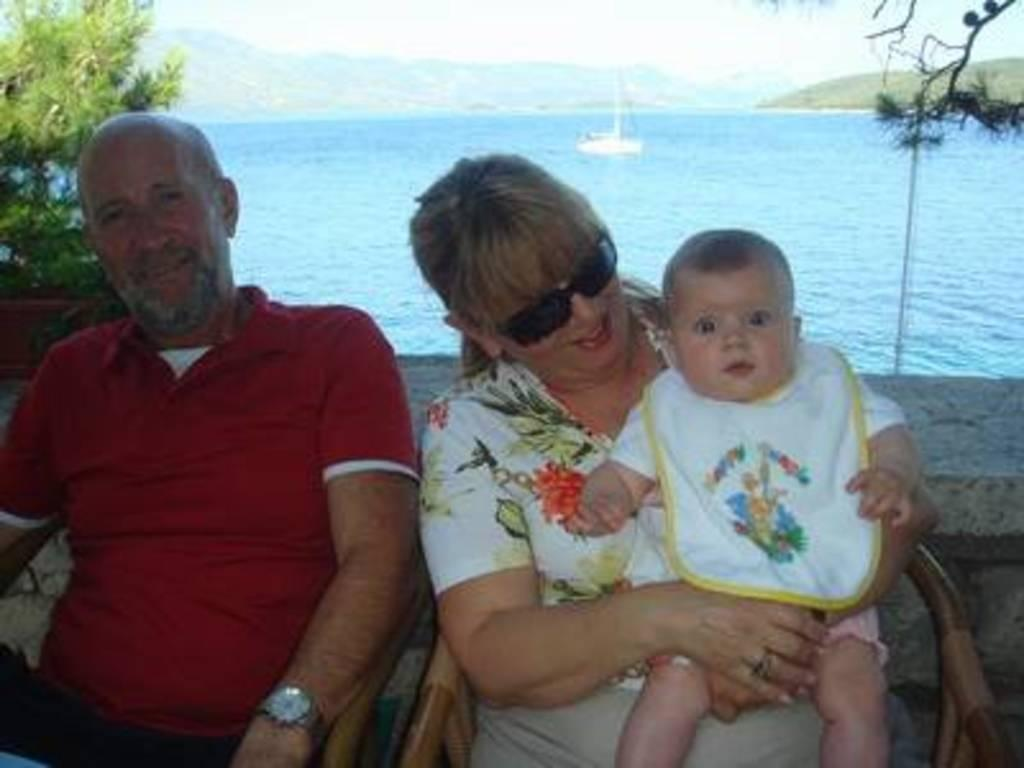Who is present in the image? There is an aged couple in the image. What are the couple doing in the image? The couple is sitting on chairs. What is the lady holding in her lap? The lady is holding a baby on her lap. What can be seen in the background of the image? There are trees, a ship sailing in the water, and mountains visible in the background. What temperature is the baby feeling in the image? The image does not provide information about the temperature or how the baby is feeling. 